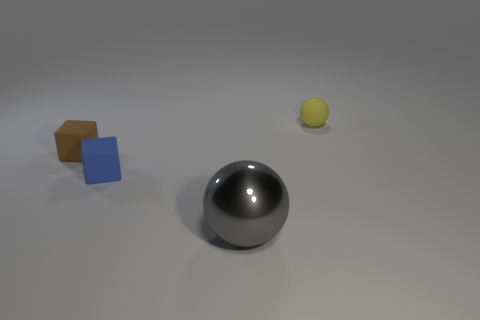Is there anything else that has the same material as the large gray thing?
Your answer should be very brief. No. How many small brown metal spheres are there?
Offer a very short reply. 0. There is a small brown matte thing; does it have the same shape as the small matte object that is behind the tiny brown cube?
Provide a succinct answer. No. Are there fewer rubber things that are right of the large shiny ball than objects that are behind the tiny brown rubber object?
Your answer should be compact. No. Is there any other thing that is the same shape as the tiny brown matte thing?
Offer a very short reply. Yes. Is the shape of the gray metallic object the same as the yellow matte object?
Give a very brief answer. Yes. The gray object is what size?
Your response must be concise. Large. What color is the object that is both in front of the tiny brown matte block and on the right side of the small blue block?
Your response must be concise. Gray. Is the number of large metal cylinders greater than the number of big balls?
Offer a terse response. No. What number of things are either large cyan things or balls that are right of the large gray shiny thing?
Ensure brevity in your answer.  1. 